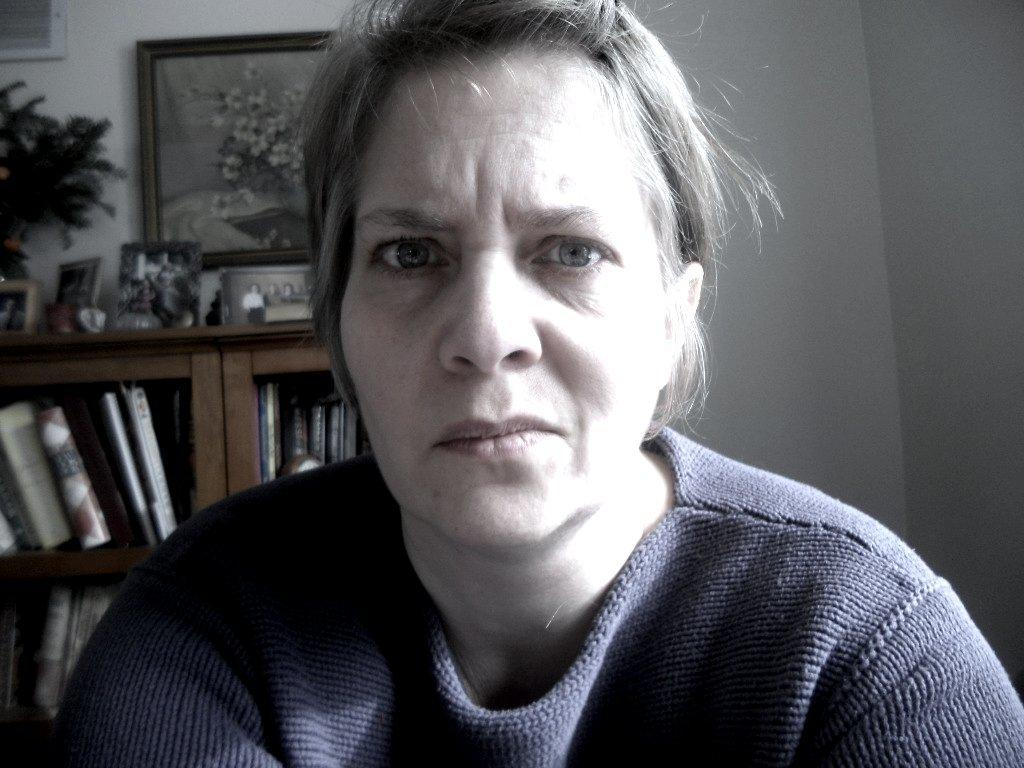Who or what is the main subject in the image? There is a person in the image. What can be seen in the background of the image? There are books in the background of the image, and they are in racks. What is the color of the wall in the background? The wall is white in color. What type of decoration is attached to the wall in the background? There are frames attached to the wall in the background. What direction is the person's tongue pointing in the image? There is no indication of the person's tongue in the image, so it cannot be determined which direction it might be pointing. 